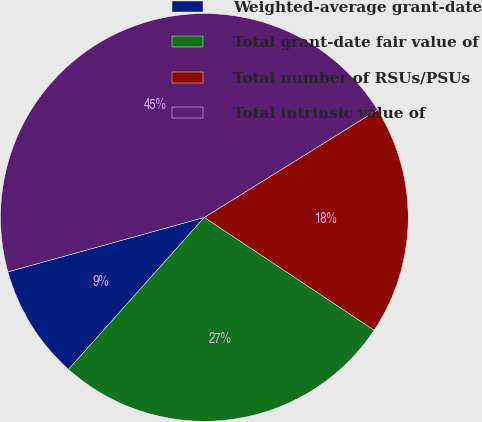Convert chart to OTSL. <chart><loc_0><loc_0><loc_500><loc_500><pie_chart><fcel>Weighted-average grant-date<fcel>Total grant-date fair value of<fcel>Total number of RSUs/PSUs<fcel>Total intrinsic value of<nl><fcel>9.09%<fcel>27.27%<fcel>18.18%<fcel>45.45%<nl></chart> 